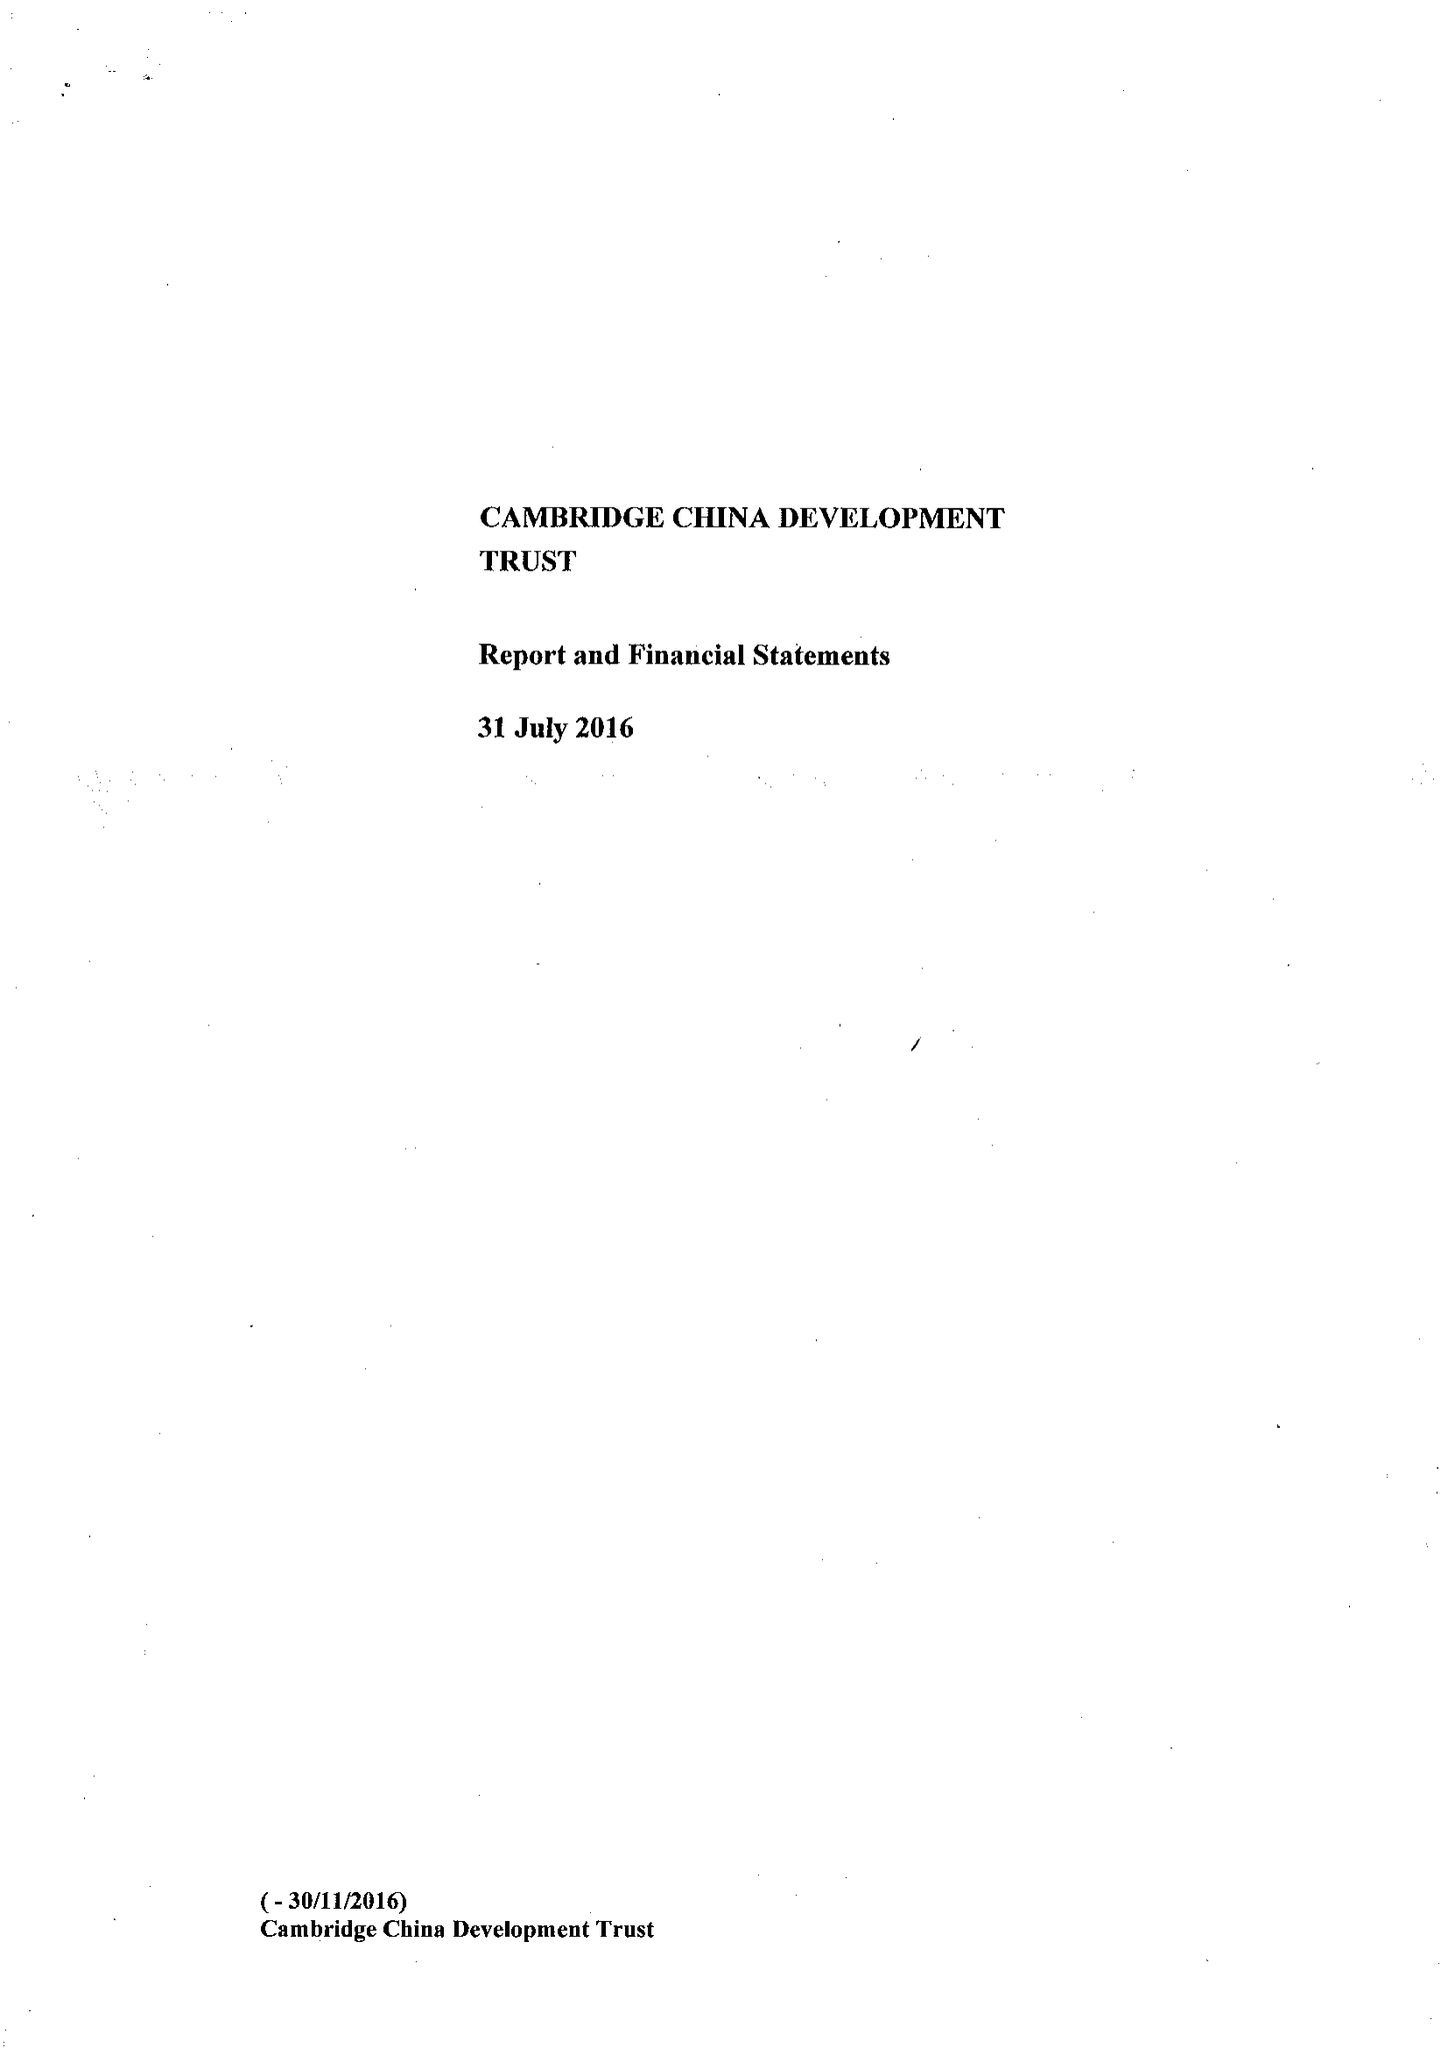What is the value for the address__post_town?
Answer the question using a single word or phrase. CAMBRIDGE 